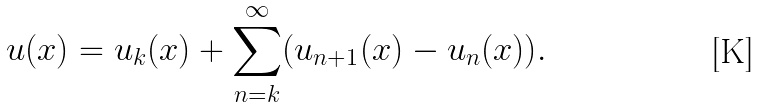<formula> <loc_0><loc_0><loc_500><loc_500>u ( x ) = u _ { k } ( x ) + \sum _ { n = k } ^ { \infty } ( u _ { n + 1 } ( x ) - u _ { n } ( x ) ) .</formula> 